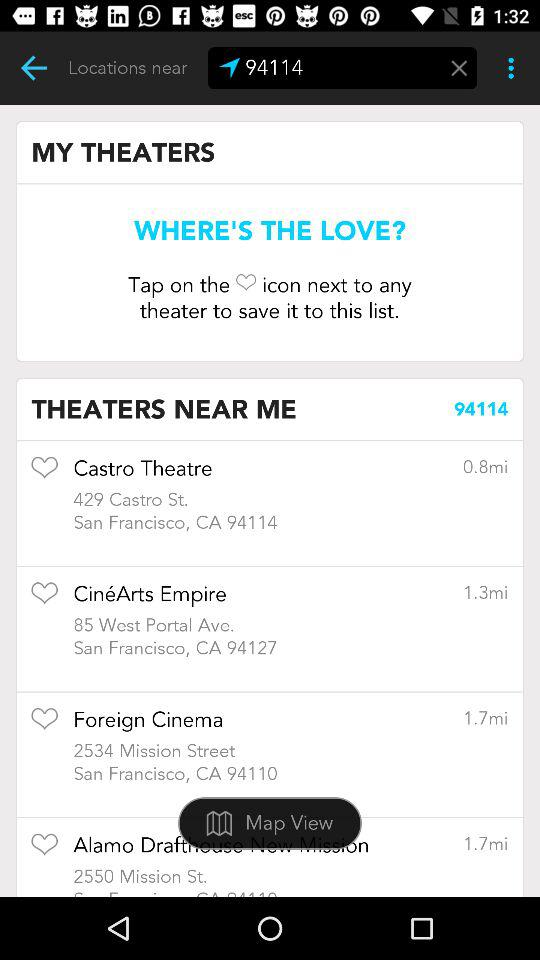What is the address of Foreign Cinema? The address of Foreign Cinema is 2534 Mission Street, San Francisco, CA 94110. 